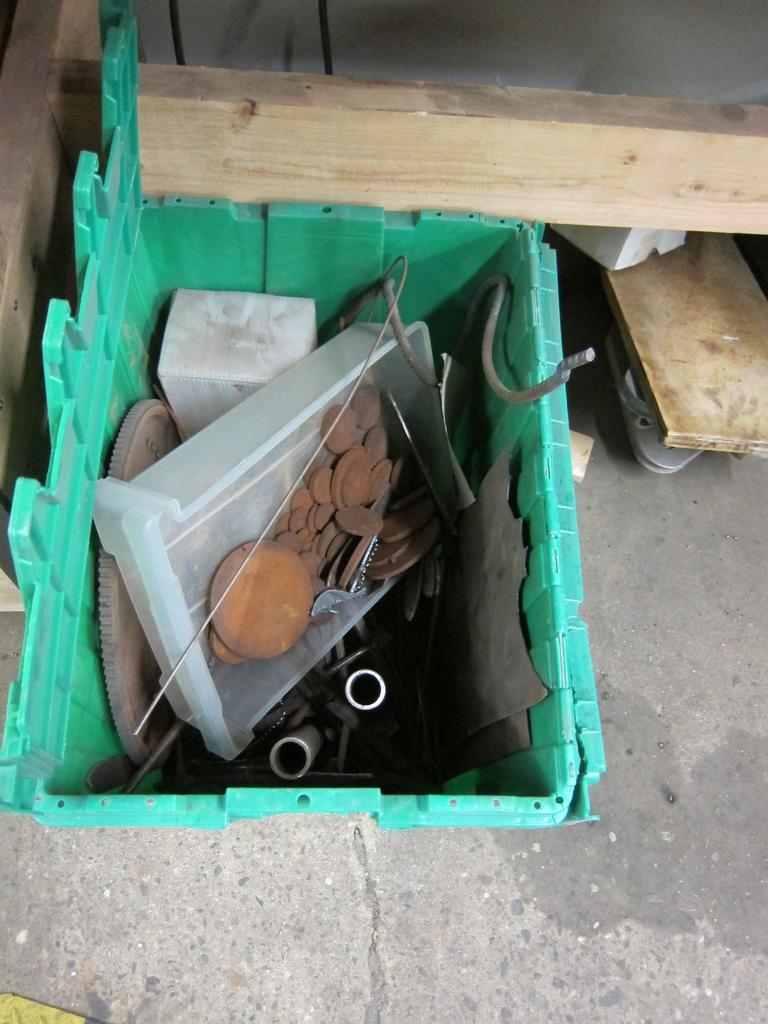What is at the bottom of the image? There is a floor at the bottom of the image. What can be seen in the middle of the image? There is a basket with a few objects in the middle of the image. What type of material are the pieces made of in the image? There are wooden pieces in the image. What type of flower is growing in the basket in the image? There are no flowers present in the image; it features a basket with wooden pieces. What substance is being used to create the wooden pieces in the image? The provided facts do not mention any specific substance used to create the wooden pieces in the image. 